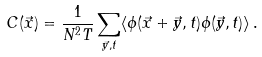Convert formula to latex. <formula><loc_0><loc_0><loc_500><loc_500>C ( \vec { x } ) = \frac { 1 } { N ^ { 2 } T } \sum _ { \vec { y } , t } \langle \phi ( \vec { x } + \vec { y } , t ) \phi ( \vec { y } , t ) \rangle \, .</formula> 